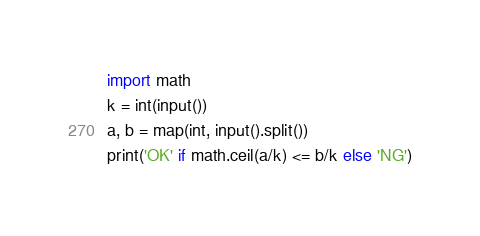Convert code to text. <code><loc_0><loc_0><loc_500><loc_500><_Python_>import math
k = int(input())
a, b = map(int, input().split())
print('OK' if math.ceil(a/k) <= b/k else 'NG')</code> 